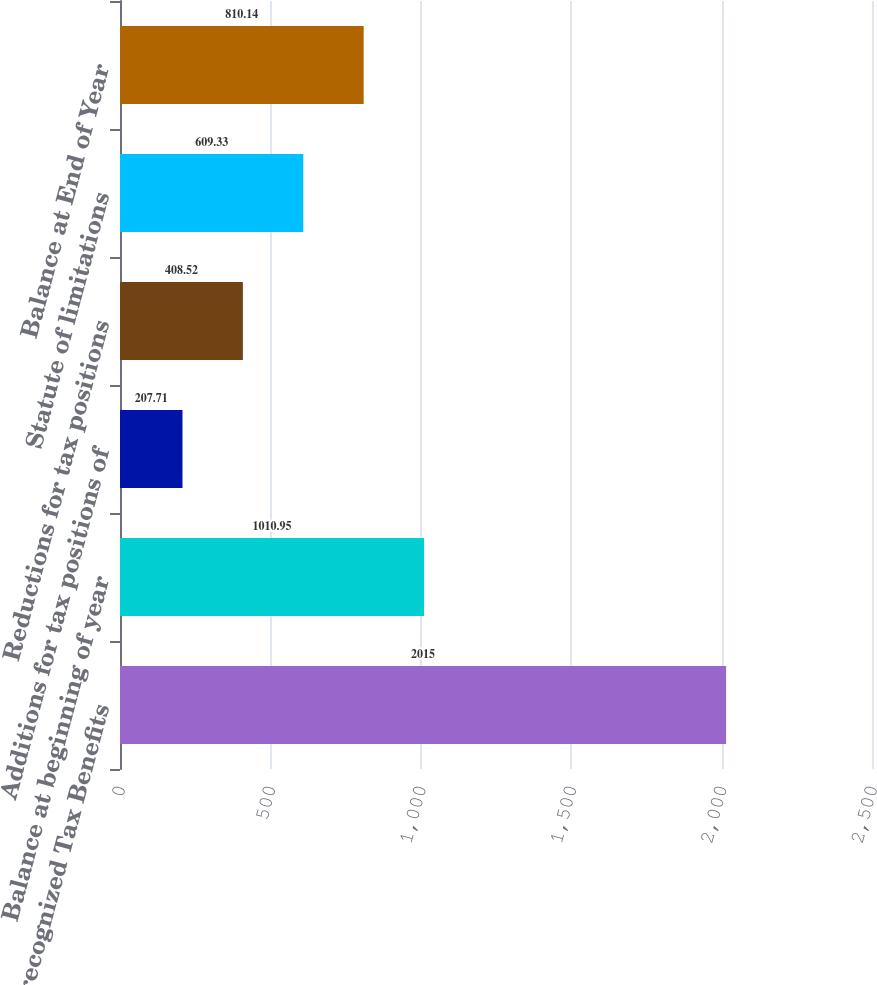Convert chart. <chart><loc_0><loc_0><loc_500><loc_500><bar_chart><fcel>Unrecognized Tax Benefits<fcel>Balance at beginning of year<fcel>Additions for tax positions of<fcel>Reductions for tax positions<fcel>Statute of limitations<fcel>Balance at End of Year<nl><fcel>2015<fcel>1010.95<fcel>207.71<fcel>408.52<fcel>609.33<fcel>810.14<nl></chart> 